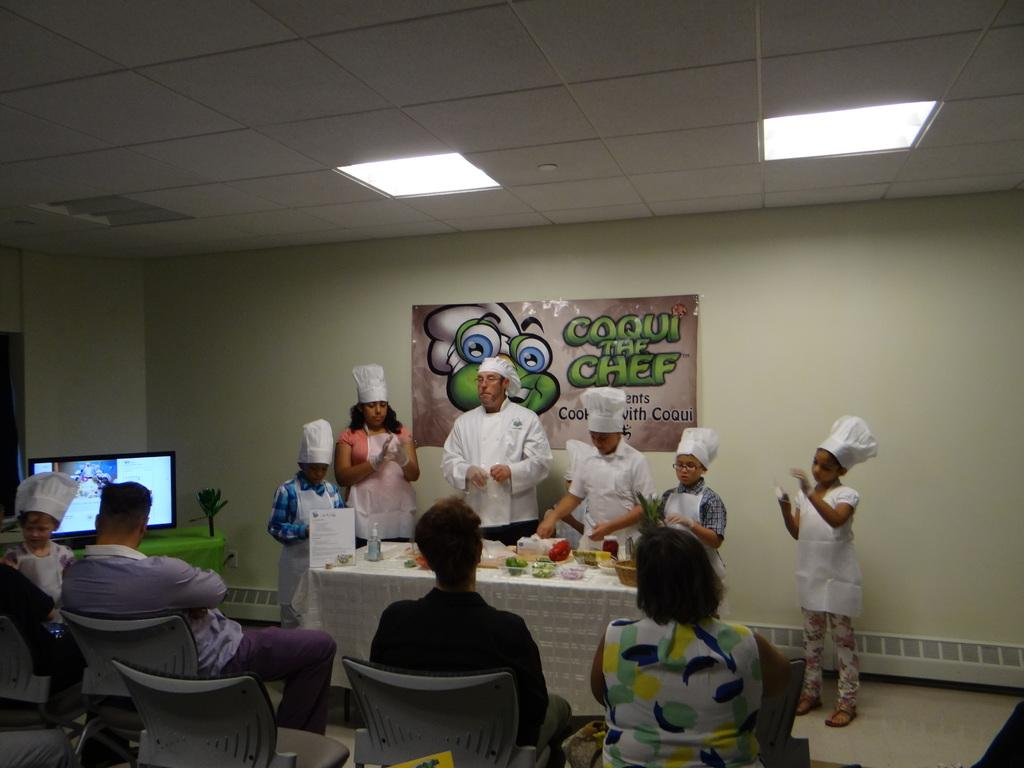How many people are in the image? There are kids and a man in the image, making a total of at least three people. What is the man wearing in the image? The man is wearing a chef dress in the image. What is on the table in the image? There is food on a table in the image. Where are the man and kids standing in the image? They are standing at a wall in the image. What is happening in the background of the image? There are people sitting on chairs in the background of the image. What type of underwear is the man wearing in the image? There is no information about the man's underwear in the image, and therefore it cannot be determined. How many forks are visible in the image? There is no mention of forks in the image, so it cannot be determined how many are visible. 